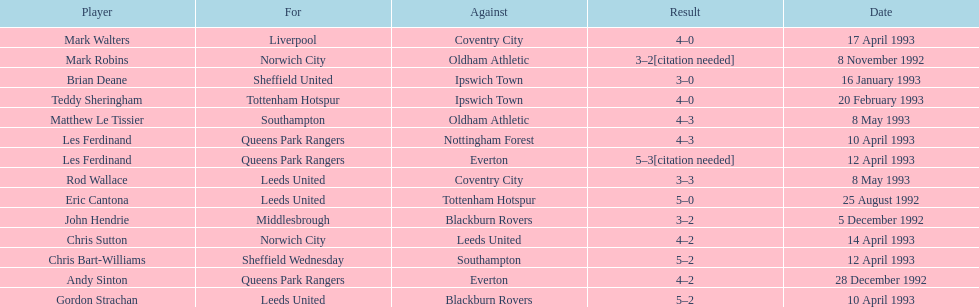Name the players for tottenham hotspur. Teddy Sheringham. 